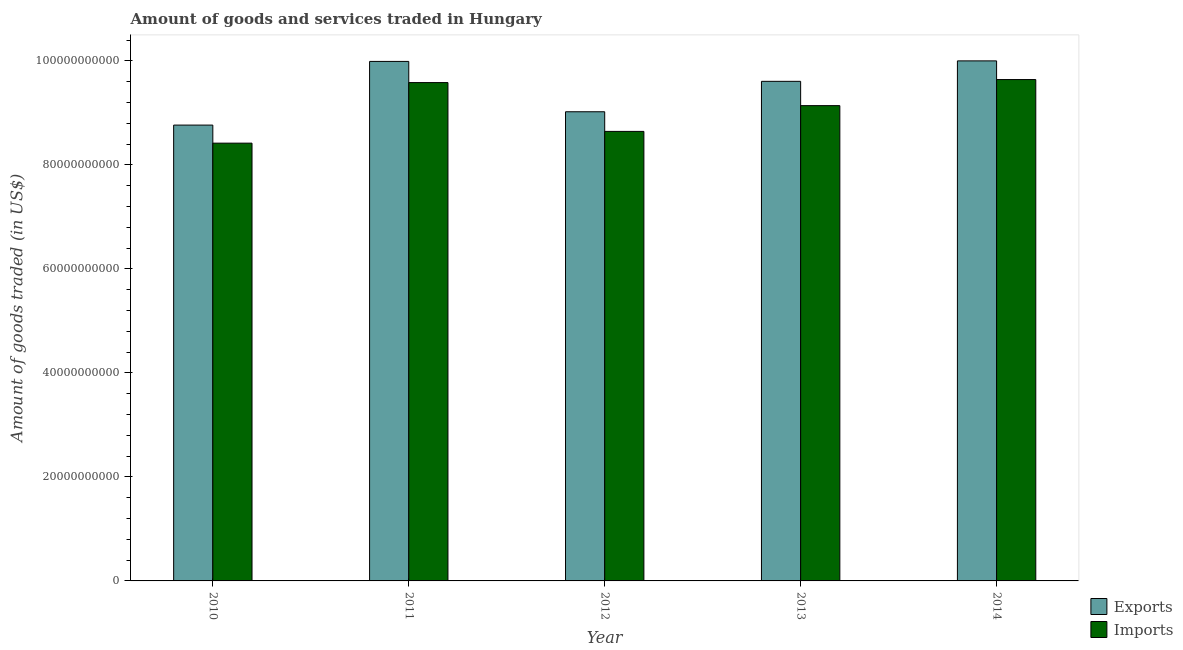How many groups of bars are there?
Provide a succinct answer. 5. Are the number of bars per tick equal to the number of legend labels?
Offer a very short reply. Yes. How many bars are there on the 4th tick from the right?
Provide a succinct answer. 2. What is the label of the 3rd group of bars from the left?
Provide a short and direct response. 2012. In how many cases, is the number of bars for a given year not equal to the number of legend labels?
Offer a very short reply. 0. What is the amount of goods exported in 2013?
Make the answer very short. 9.61e+1. Across all years, what is the maximum amount of goods imported?
Make the answer very short. 9.64e+1. Across all years, what is the minimum amount of goods exported?
Keep it short and to the point. 8.77e+1. In which year was the amount of goods imported maximum?
Make the answer very short. 2014. In which year was the amount of goods exported minimum?
Your answer should be very brief. 2010. What is the total amount of goods exported in the graph?
Provide a short and direct response. 4.74e+11. What is the difference between the amount of goods imported in 2013 and that in 2014?
Your answer should be compact. -5.02e+09. What is the difference between the amount of goods imported in 2012 and the amount of goods exported in 2010?
Provide a succinct answer. 2.26e+09. What is the average amount of goods imported per year?
Your answer should be compact. 9.09e+1. In the year 2010, what is the difference between the amount of goods exported and amount of goods imported?
Your answer should be very brief. 0. What is the ratio of the amount of goods imported in 2012 to that in 2013?
Ensure brevity in your answer.  0.95. What is the difference between the highest and the second highest amount of goods exported?
Ensure brevity in your answer.  1.04e+08. What is the difference between the highest and the lowest amount of goods imported?
Give a very brief answer. 1.22e+1. Is the sum of the amount of goods imported in 2013 and 2014 greater than the maximum amount of goods exported across all years?
Your response must be concise. Yes. What does the 2nd bar from the left in 2014 represents?
Offer a very short reply. Imports. What does the 1st bar from the right in 2012 represents?
Your response must be concise. Imports. Are all the bars in the graph horizontal?
Give a very brief answer. No. Are the values on the major ticks of Y-axis written in scientific E-notation?
Provide a short and direct response. No. How are the legend labels stacked?
Your answer should be very brief. Vertical. What is the title of the graph?
Offer a terse response. Amount of goods and services traded in Hungary. Does "Rural" appear as one of the legend labels in the graph?
Your answer should be compact. No. What is the label or title of the X-axis?
Offer a very short reply. Year. What is the label or title of the Y-axis?
Your response must be concise. Amount of goods traded (in US$). What is the Amount of goods traded (in US$) in Exports in 2010?
Ensure brevity in your answer.  8.77e+1. What is the Amount of goods traded (in US$) in Imports in 2010?
Offer a terse response. 8.42e+1. What is the Amount of goods traded (in US$) in Exports in 2011?
Provide a succinct answer. 9.99e+1. What is the Amount of goods traded (in US$) of Imports in 2011?
Offer a very short reply. 9.58e+1. What is the Amount of goods traded (in US$) in Exports in 2012?
Your response must be concise. 9.02e+1. What is the Amount of goods traded (in US$) in Imports in 2012?
Your answer should be very brief. 8.65e+1. What is the Amount of goods traded (in US$) in Exports in 2013?
Make the answer very short. 9.61e+1. What is the Amount of goods traded (in US$) in Imports in 2013?
Offer a terse response. 9.14e+1. What is the Amount of goods traded (in US$) in Exports in 2014?
Provide a short and direct response. 1.00e+11. What is the Amount of goods traded (in US$) in Imports in 2014?
Provide a short and direct response. 9.64e+1. Across all years, what is the maximum Amount of goods traded (in US$) in Exports?
Make the answer very short. 1.00e+11. Across all years, what is the maximum Amount of goods traded (in US$) of Imports?
Provide a short and direct response. 9.64e+1. Across all years, what is the minimum Amount of goods traded (in US$) in Exports?
Give a very brief answer. 8.77e+1. Across all years, what is the minimum Amount of goods traded (in US$) in Imports?
Provide a short and direct response. 8.42e+1. What is the total Amount of goods traded (in US$) in Exports in the graph?
Provide a short and direct response. 4.74e+11. What is the total Amount of goods traded (in US$) in Imports in the graph?
Ensure brevity in your answer.  4.54e+11. What is the difference between the Amount of goods traded (in US$) of Exports in 2010 and that in 2011?
Make the answer very short. -1.22e+1. What is the difference between the Amount of goods traded (in US$) of Imports in 2010 and that in 2011?
Provide a short and direct response. -1.16e+1. What is the difference between the Amount of goods traded (in US$) in Exports in 2010 and that in 2012?
Provide a succinct answer. -2.56e+09. What is the difference between the Amount of goods traded (in US$) in Imports in 2010 and that in 2012?
Your answer should be very brief. -2.26e+09. What is the difference between the Amount of goods traded (in US$) in Exports in 2010 and that in 2013?
Ensure brevity in your answer.  -8.41e+09. What is the difference between the Amount of goods traded (in US$) in Imports in 2010 and that in 2013?
Make the answer very short. -7.21e+09. What is the difference between the Amount of goods traded (in US$) in Exports in 2010 and that in 2014?
Your response must be concise. -1.23e+1. What is the difference between the Amount of goods traded (in US$) in Imports in 2010 and that in 2014?
Offer a very short reply. -1.22e+1. What is the difference between the Amount of goods traded (in US$) in Exports in 2011 and that in 2012?
Your response must be concise. 9.68e+09. What is the difference between the Amount of goods traded (in US$) of Imports in 2011 and that in 2012?
Ensure brevity in your answer.  9.39e+09. What is the difference between the Amount of goods traded (in US$) of Exports in 2011 and that in 2013?
Your answer should be compact. 3.83e+09. What is the difference between the Amount of goods traded (in US$) in Imports in 2011 and that in 2013?
Ensure brevity in your answer.  4.43e+09. What is the difference between the Amount of goods traded (in US$) in Exports in 2011 and that in 2014?
Provide a succinct answer. -1.04e+08. What is the difference between the Amount of goods traded (in US$) of Imports in 2011 and that in 2014?
Ensure brevity in your answer.  -5.85e+08. What is the difference between the Amount of goods traded (in US$) in Exports in 2012 and that in 2013?
Provide a short and direct response. -5.85e+09. What is the difference between the Amount of goods traded (in US$) in Imports in 2012 and that in 2013?
Give a very brief answer. -4.96e+09. What is the difference between the Amount of goods traded (in US$) in Exports in 2012 and that in 2014?
Give a very brief answer. -9.79e+09. What is the difference between the Amount of goods traded (in US$) of Imports in 2012 and that in 2014?
Offer a very short reply. -9.97e+09. What is the difference between the Amount of goods traded (in US$) of Exports in 2013 and that in 2014?
Offer a terse response. -3.94e+09. What is the difference between the Amount of goods traded (in US$) of Imports in 2013 and that in 2014?
Give a very brief answer. -5.02e+09. What is the difference between the Amount of goods traded (in US$) in Exports in 2010 and the Amount of goods traded (in US$) in Imports in 2011?
Offer a terse response. -8.17e+09. What is the difference between the Amount of goods traded (in US$) in Exports in 2010 and the Amount of goods traded (in US$) in Imports in 2012?
Your answer should be compact. 1.21e+09. What is the difference between the Amount of goods traded (in US$) of Exports in 2010 and the Amount of goods traded (in US$) of Imports in 2013?
Your answer should be very brief. -3.74e+09. What is the difference between the Amount of goods traded (in US$) in Exports in 2010 and the Amount of goods traded (in US$) in Imports in 2014?
Give a very brief answer. -8.76e+09. What is the difference between the Amount of goods traded (in US$) of Exports in 2011 and the Amount of goods traded (in US$) of Imports in 2012?
Provide a succinct answer. 1.35e+1. What is the difference between the Amount of goods traded (in US$) in Exports in 2011 and the Amount of goods traded (in US$) in Imports in 2013?
Give a very brief answer. 8.50e+09. What is the difference between the Amount of goods traded (in US$) of Exports in 2011 and the Amount of goods traded (in US$) of Imports in 2014?
Give a very brief answer. 3.49e+09. What is the difference between the Amount of goods traded (in US$) of Exports in 2012 and the Amount of goods traded (in US$) of Imports in 2013?
Make the answer very short. -1.18e+09. What is the difference between the Amount of goods traded (in US$) in Exports in 2012 and the Amount of goods traded (in US$) in Imports in 2014?
Make the answer very short. -6.20e+09. What is the difference between the Amount of goods traded (in US$) in Exports in 2013 and the Amount of goods traded (in US$) in Imports in 2014?
Offer a very short reply. -3.44e+08. What is the average Amount of goods traded (in US$) in Exports per year?
Your response must be concise. 9.48e+1. What is the average Amount of goods traded (in US$) in Imports per year?
Offer a terse response. 9.09e+1. In the year 2010, what is the difference between the Amount of goods traded (in US$) of Exports and Amount of goods traded (in US$) of Imports?
Your answer should be very brief. 3.47e+09. In the year 2011, what is the difference between the Amount of goods traded (in US$) of Exports and Amount of goods traded (in US$) of Imports?
Ensure brevity in your answer.  4.07e+09. In the year 2012, what is the difference between the Amount of goods traded (in US$) in Exports and Amount of goods traded (in US$) in Imports?
Give a very brief answer. 3.78e+09. In the year 2013, what is the difference between the Amount of goods traded (in US$) in Exports and Amount of goods traded (in US$) in Imports?
Make the answer very short. 4.67e+09. In the year 2014, what is the difference between the Amount of goods traded (in US$) of Exports and Amount of goods traded (in US$) of Imports?
Your answer should be compact. 3.59e+09. What is the ratio of the Amount of goods traded (in US$) of Exports in 2010 to that in 2011?
Provide a succinct answer. 0.88. What is the ratio of the Amount of goods traded (in US$) of Imports in 2010 to that in 2011?
Your answer should be very brief. 0.88. What is the ratio of the Amount of goods traded (in US$) of Exports in 2010 to that in 2012?
Offer a terse response. 0.97. What is the ratio of the Amount of goods traded (in US$) of Imports in 2010 to that in 2012?
Provide a short and direct response. 0.97. What is the ratio of the Amount of goods traded (in US$) of Exports in 2010 to that in 2013?
Ensure brevity in your answer.  0.91. What is the ratio of the Amount of goods traded (in US$) of Imports in 2010 to that in 2013?
Offer a terse response. 0.92. What is the ratio of the Amount of goods traded (in US$) in Exports in 2010 to that in 2014?
Your answer should be very brief. 0.88. What is the ratio of the Amount of goods traded (in US$) of Imports in 2010 to that in 2014?
Make the answer very short. 0.87. What is the ratio of the Amount of goods traded (in US$) in Exports in 2011 to that in 2012?
Keep it short and to the point. 1.11. What is the ratio of the Amount of goods traded (in US$) in Imports in 2011 to that in 2012?
Your response must be concise. 1.11. What is the ratio of the Amount of goods traded (in US$) of Exports in 2011 to that in 2013?
Keep it short and to the point. 1.04. What is the ratio of the Amount of goods traded (in US$) in Imports in 2011 to that in 2013?
Provide a succinct answer. 1.05. What is the ratio of the Amount of goods traded (in US$) in Exports in 2011 to that in 2014?
Your response must be concise. 1. What is the ratio of the Amount of goods traded (in US$) in Imports in 2011 to that in 2014?
Offer a very short reply. 0.99. What is the ratio of the Amount of goods traded (in US$) in Exports in 2012 to that in 2013?
Provide a short and direct response. 0.94. What is the ratio of the Amount of goods traded (in US$) of Imports in 2012 to that in 2013?
Make the answer very short. 0.95. What is the ratio of the Amount of goods traded (in US$) of Exports in 2012 to that in 2014?
Your response must be concise. 0.9. What is the ratio of the Amount of goods traded (in US$) in Imports in 2012 to that in 2014?
Offer a terse response. 0.9. What is the ratio of the Amount of goods traded (in US$) in Exports in 2013 to that in 2014?
Provide a succinct answer. 0.96. What is the ratio of the Amount of goods traded (in US$) in Imports in 2013 to that in 2014?
Ensure brevity in your answer.  0.95. What is the difference between the highest and the second highest Amount of goods traded (in US$) of Exports?
Provide a succinct answer. 1.04e+08. What is the difference between the highest and the second highest Amount of goods traded (in US$) of Imports?
Ensure brevity in your answer.  5.85e+08. What is the difference between the highest and the lowest Amount of goods traded (in US$) in Exports?
Your response must be concise. 1.23e+1. What is the difference between the highest and the lowest Amount of goods traded (in US$) of Imports?
Ensure brevity in your answer.  1.22e+1. 